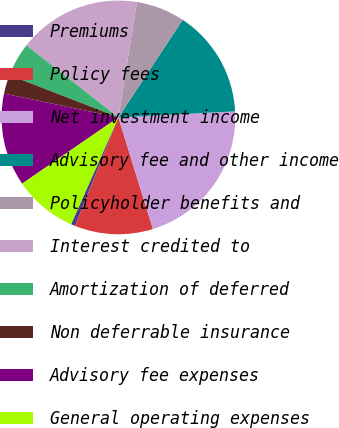<chart> <loc_0><loc_0><loc_500><loc_500><pie_chart><fcel>Premiums<fcel>Policy fees<fcel>Net investment income<fcel>Advisory fee and other income<fcel>Policyholder benefits and<fcel>Interest credited to<fcel>Amortization of deferred<fcel>Non deferrable insurance<fcel>Advisory fee expenses<fcel>General operating expenses<nl><fcel>0.59%<fcel>10.82%<fcel>21.05%<fcel>14.91%<fcel>6.73%<fcel>16.96%<fcel>4.68%<fcel>2.63%<fcel>12.86%<fcel>8.77%<nl></chart> 